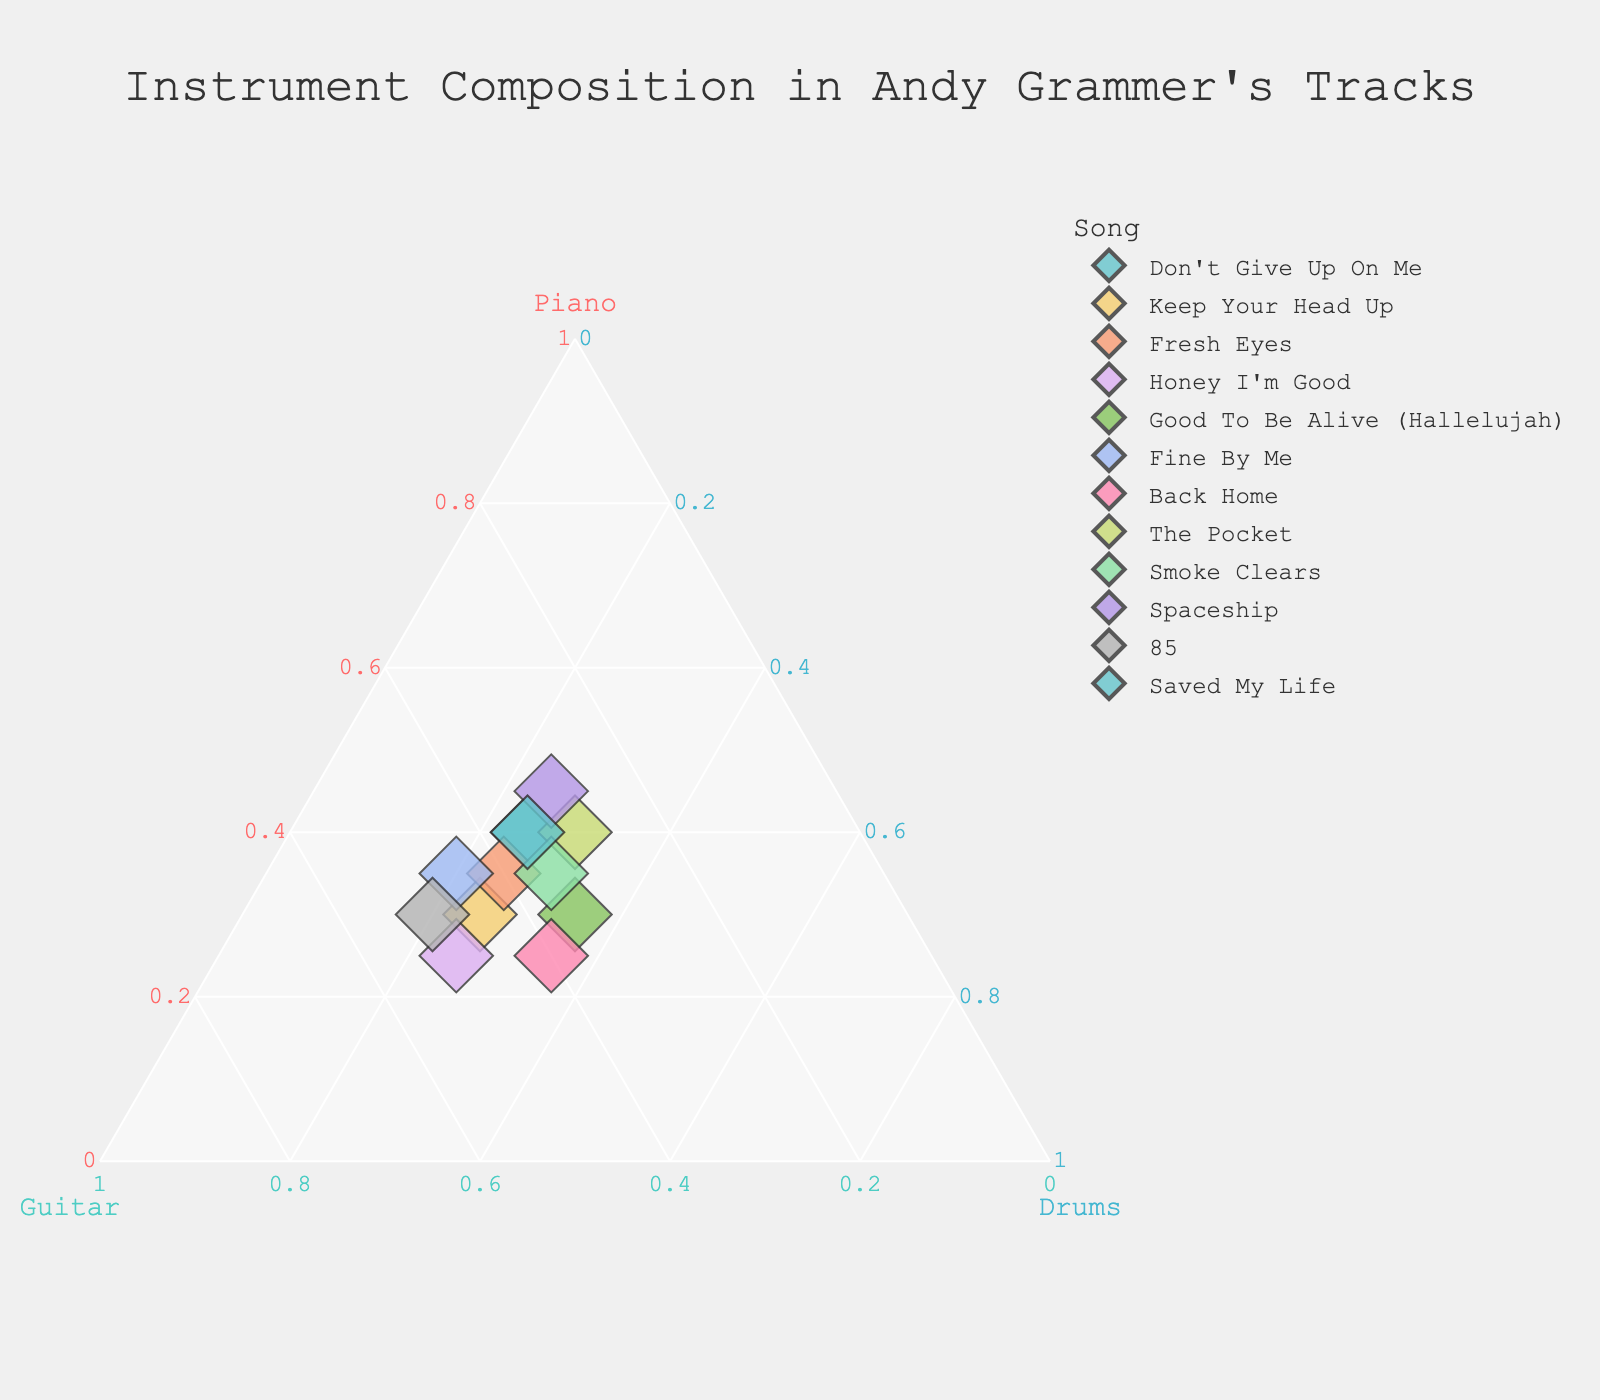What's the title of the figure? The title is often placed at the top center of a plot. In this case, the title is located there as well.
Answer: Instrument Composition in Andy Grammer's Tracks How many songs are represented in the figure? Each song corresponds to a different data point on the plot, and you can count each of these points. There are 12 such points.
Answer: 12 Which song has the highest proportion of Piano? To determine this, look for the point farthest towards the 'Piano' axis. "Spaceship" is the closest to the Piano axis.
Answer: Spaceship Which song has an equal proportion of Drums as "Good To Be Alive (Hallelujah)"? "Good To Be Alive (Hallelujah)" has 35% Drums. Another point with 35% Drums is "Back Home".
Answer: Back Home Is there any song where the proportion of Guitar is greater than 50%? None of the songs surpass the 50% mark for Guitar.
Answer: No What is the combined proportion of Piano and Drums for "Fine By Me"? The values for "Fine By Me" are 35% Piano and 20% Drums. Add these together: 35% + 20% = 55%.
Answer: 55% Which song has the smallest percentage of Drums? To identify the song with the smallest percentage of Drums, look for the point that is closest to the base of the Drums axis. Both "Fine By Me" and "85" have the smallest percentage, which is 20%.
Answer: Fine By Me and 85 Which two songs have the same Instrumental composition? The songs with identical points have the same composition. "Don't Give Up On Me" and "Saved My Life" both have 40% Piano, 35% Guitar, and 25% Drums.
Answer: Don't Give Up On Me and Saved My Life Which axis is represented by the color "#FF6B6B"? Refer to the axis labels and their colors. The Piano axis is labeled in "#FF6B6B".
Answer: Piano How many songs have a Guitar proportion of 40% or more? Scan the graph for points where the Guitar value is 40% or higher. "Keep Your Head Up", "Fresh Eyes", "Honey I'm Good", "Fine By Me", "Back Home", "85" total six songs fit this criterion.
Answer: 6 